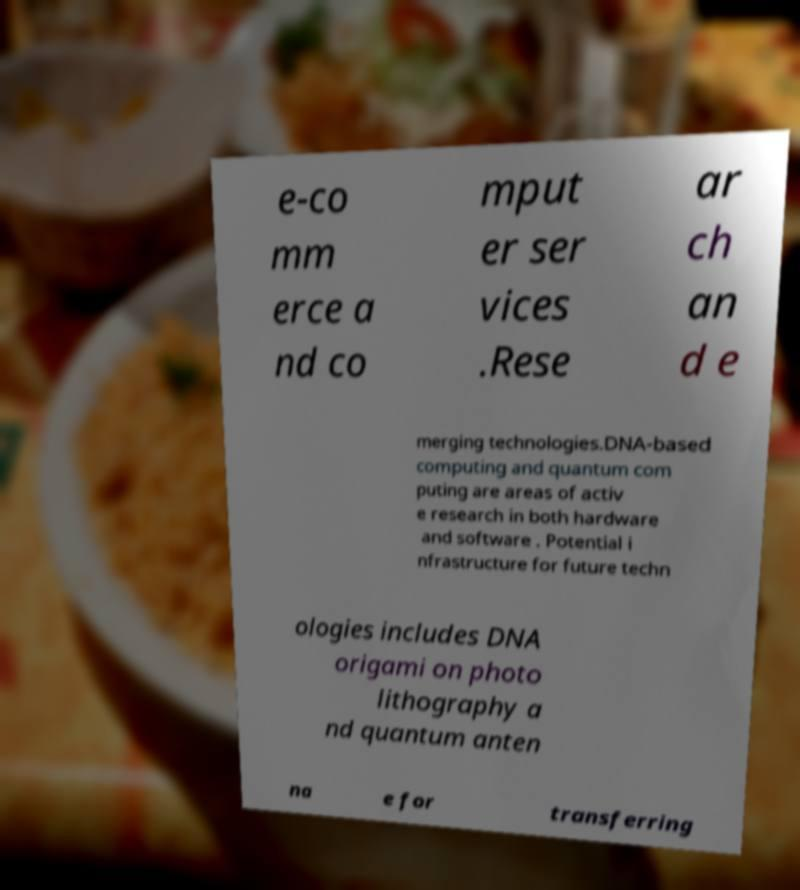What messages or text are displayed in this image? I need them in a readable, typed format. e-co mm erce a nd co mput er ser vices .Rese ar ch an d e merging technologies.DNA-based computing and quantum com puting are areas of activ e research in both hardware and software . Potential i nfrastructure for future techn ologies includes DNA origami on photo lithography a nd quantum anten na e for transferring 